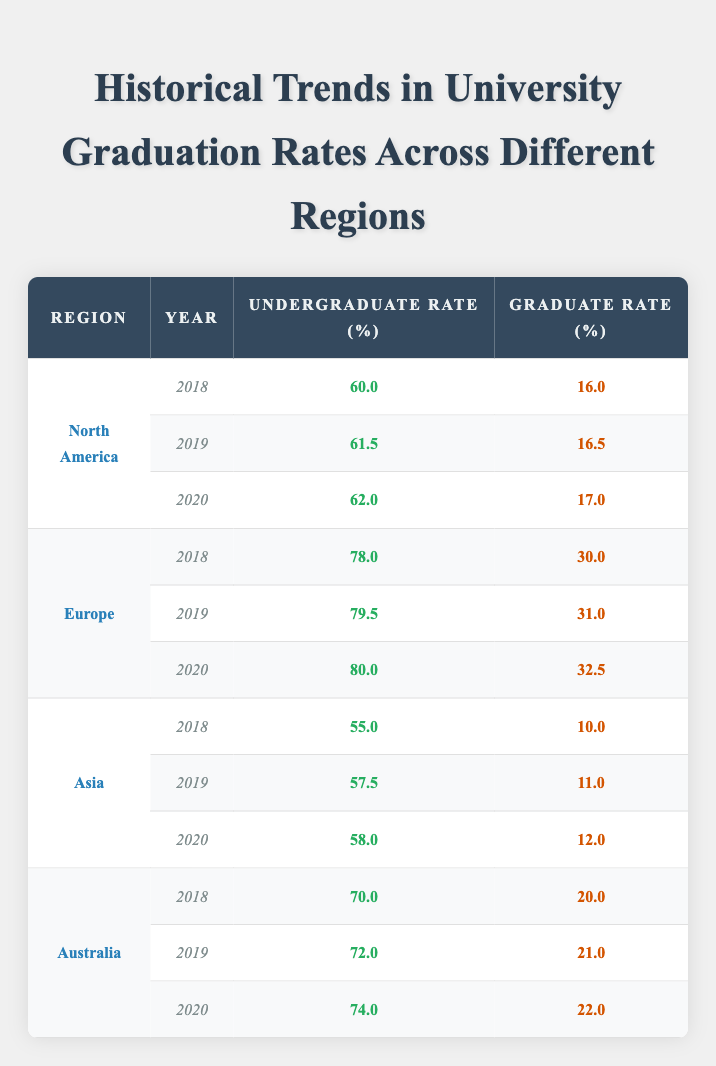What was the undergraduate graduation rate in Europe in 2020? The table shows the graduation rates by region and year. For Europe in 2020, the undergraduate rate is listed as 80.0.
Answer: 80.0 What is the graduate graduation rate in North America for the year 2019? Referring to the table, the graduate rate for North America in 2019 is displayed as 16.5.
Answer: 16.5 Which region had the highest undergraduate graduation rate in 2018? By examining the 2018 data, Europe has the highest undergraduate graduation rate at 78.0, compared to the other regions.
Answer: Europe What is the difference in undergraduate graduation rates between Asia in 2018 and Australia in 2020? The table states that Asia's undergraduate rate in 2018 is 55.0, and Australia's rate in 2020 is 74.0. The difference is 74.0 - 55.0 = 19.0.
Answer: 19.0 Is it true that graduate graduation rates have consistently increased in North America from 2018 to 2020? Checking the table, North America's graduate rates are 16.0 in 2018, 16.5 in 2019, and 17.0 in 2020, showing a consistent increase. Thus, the statement is true.
Answer: Yes What is the average graduate graduation rate in Europe over the years 2018 to 2020? The graduate rates for Europe are 30.0 in 2018, 31.0 in 2019, and 32.5 in 2020. Their sum is 30.0 + 31.0 + 32.5 = 93.5. Dividing by 3 gives an average of 93.5 / 3 = 31.17.
Answer: 31.17 Comparing all regions, which one had the lowest graduate graduation rate in 2019? In 2019, North America had a graduate rate of 16.5, Asia's was 11.0, Europe had 31.0, and Australia was at 21.0. Asia's rate is the lowest of these, at 11.0.
Answer: Asia What was the total undergraduate graduation rate for Australia from 2018 to 2020? The rates for Australia are 70.0 in 2018, 72.0 in 2019, and 74.0 in 2020. Adding them gives 70.0 + 72.0 + 74.0 = 216.0.
Answer: 216.0 Did Europe have a higher undergraduate graduation rate than Asia in 2019? In 2019, Europe had an undergraduate rate of 79.5, whereas Asia's was only 57.5. Hence, Europe did have a higher rate in that year.
Answer: Yes 